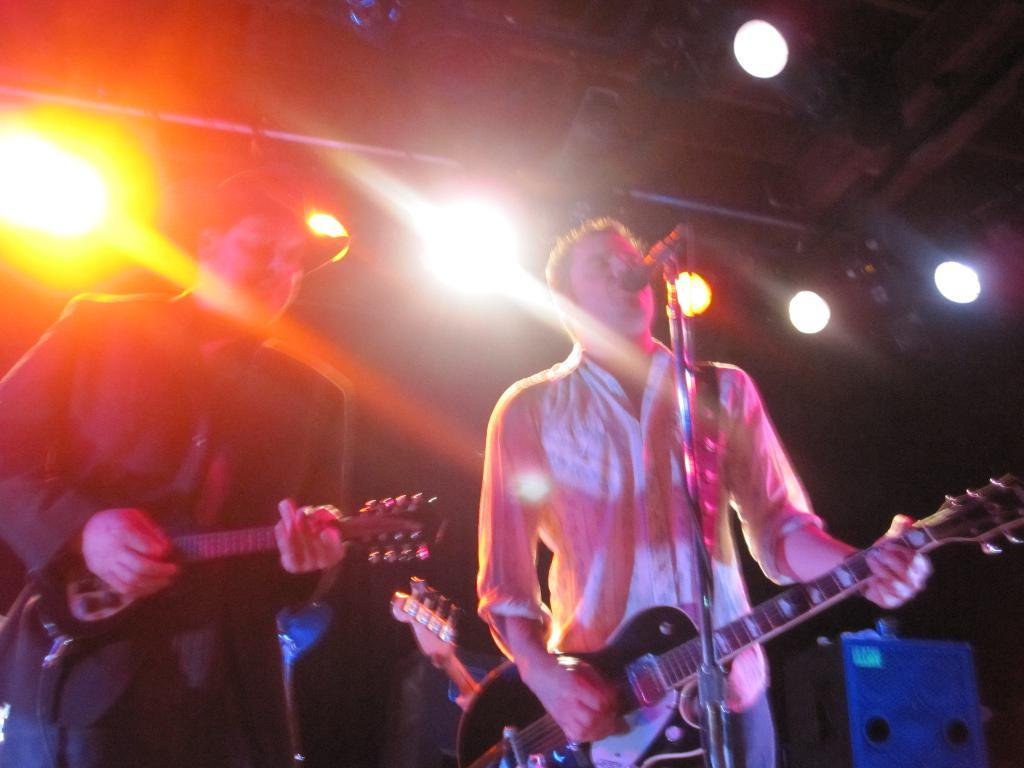How many people are in the image? There are two persons standing in the image. What are the persons holding in the image? The persons are holding guitars. What object is present for amplifying sound in the image? There is a microphone with a stand in the image. What can be seen in the background of the image? Lights are visible in the background of the image. What is one person wearing on their head? One person is wearing a cap. What type of event is the mom attending in the image? There is no mention of a mom or an event in the image; it features two persons holding guitars, a microphone with a stand, and lights in the background. What type of shade is being used to protect the instruments from sunlight in the image? There is no shade present in the image, and the instruments are not being protected from sunlight. 